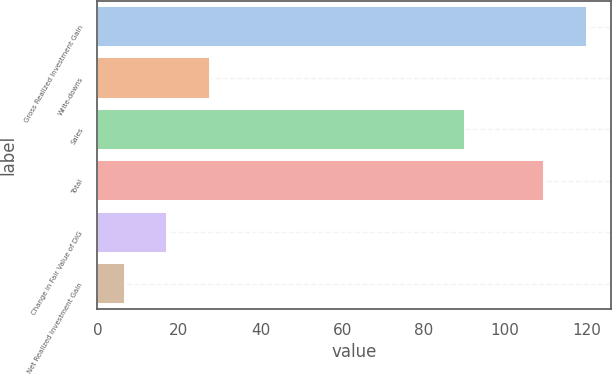Convert chart. <chart><loc_0><loc_0><loc_500><loc_500><bar_chart><fcel>Gross Realized Investment Gain<fcel>Write-downs<fcel>Sales<fcel>Total<fcel>Change in Fair Value of DIG<fcel>Net Realized Investment Gain<nl><fcel>120.01<fcel>27.52<fcel>90.2<fcel>109.6<fcel>17.11<fcel>6.7<nl></chart> 